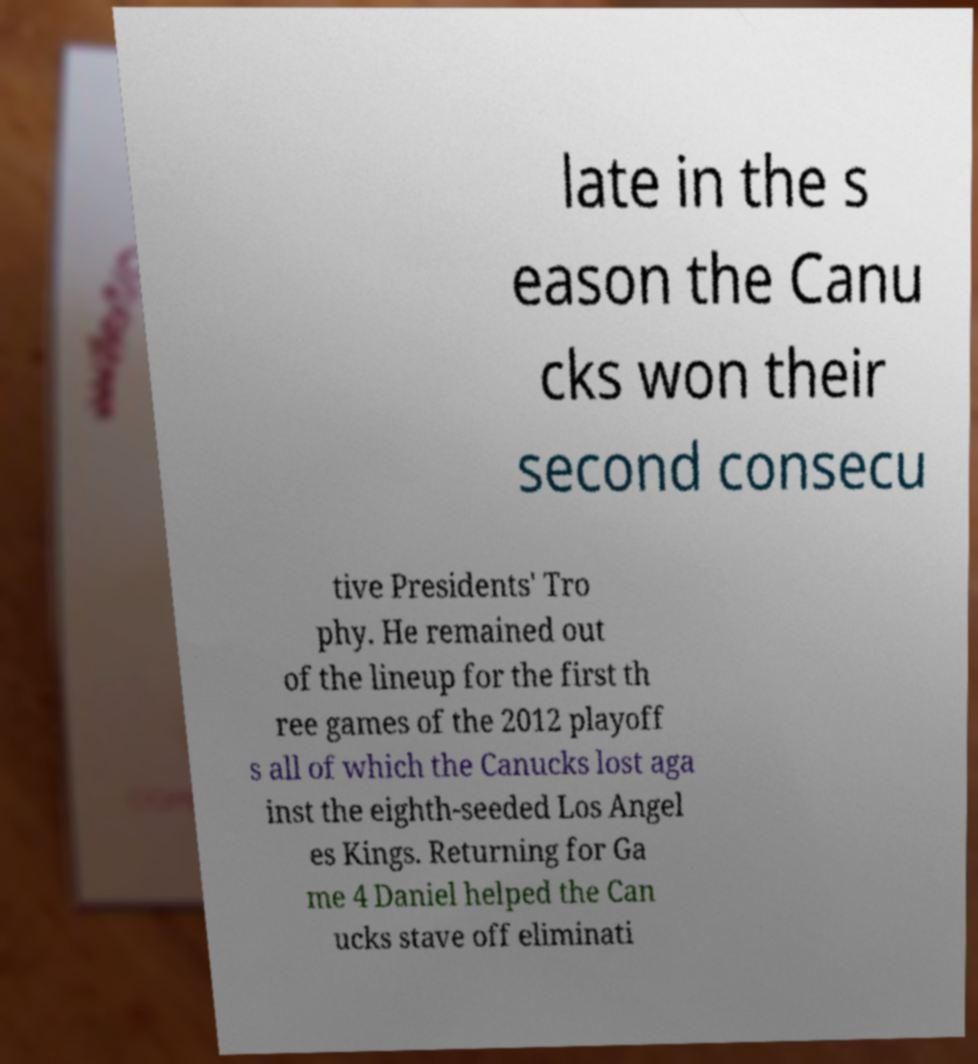For documentation purposes, I need the text within this image transcribed. Could you provide that? late in the s eason the Canu cks won their second consecu tive Presidents' Tro phy. He remained out of the lineup for the first th ree games of the 2012 playoff s all of which the Canucks lost aga inst the eighth-seeded Los Angel es Kings. Returning for Ga me 4 Daniel helped the Can ucks stave off eliminati 